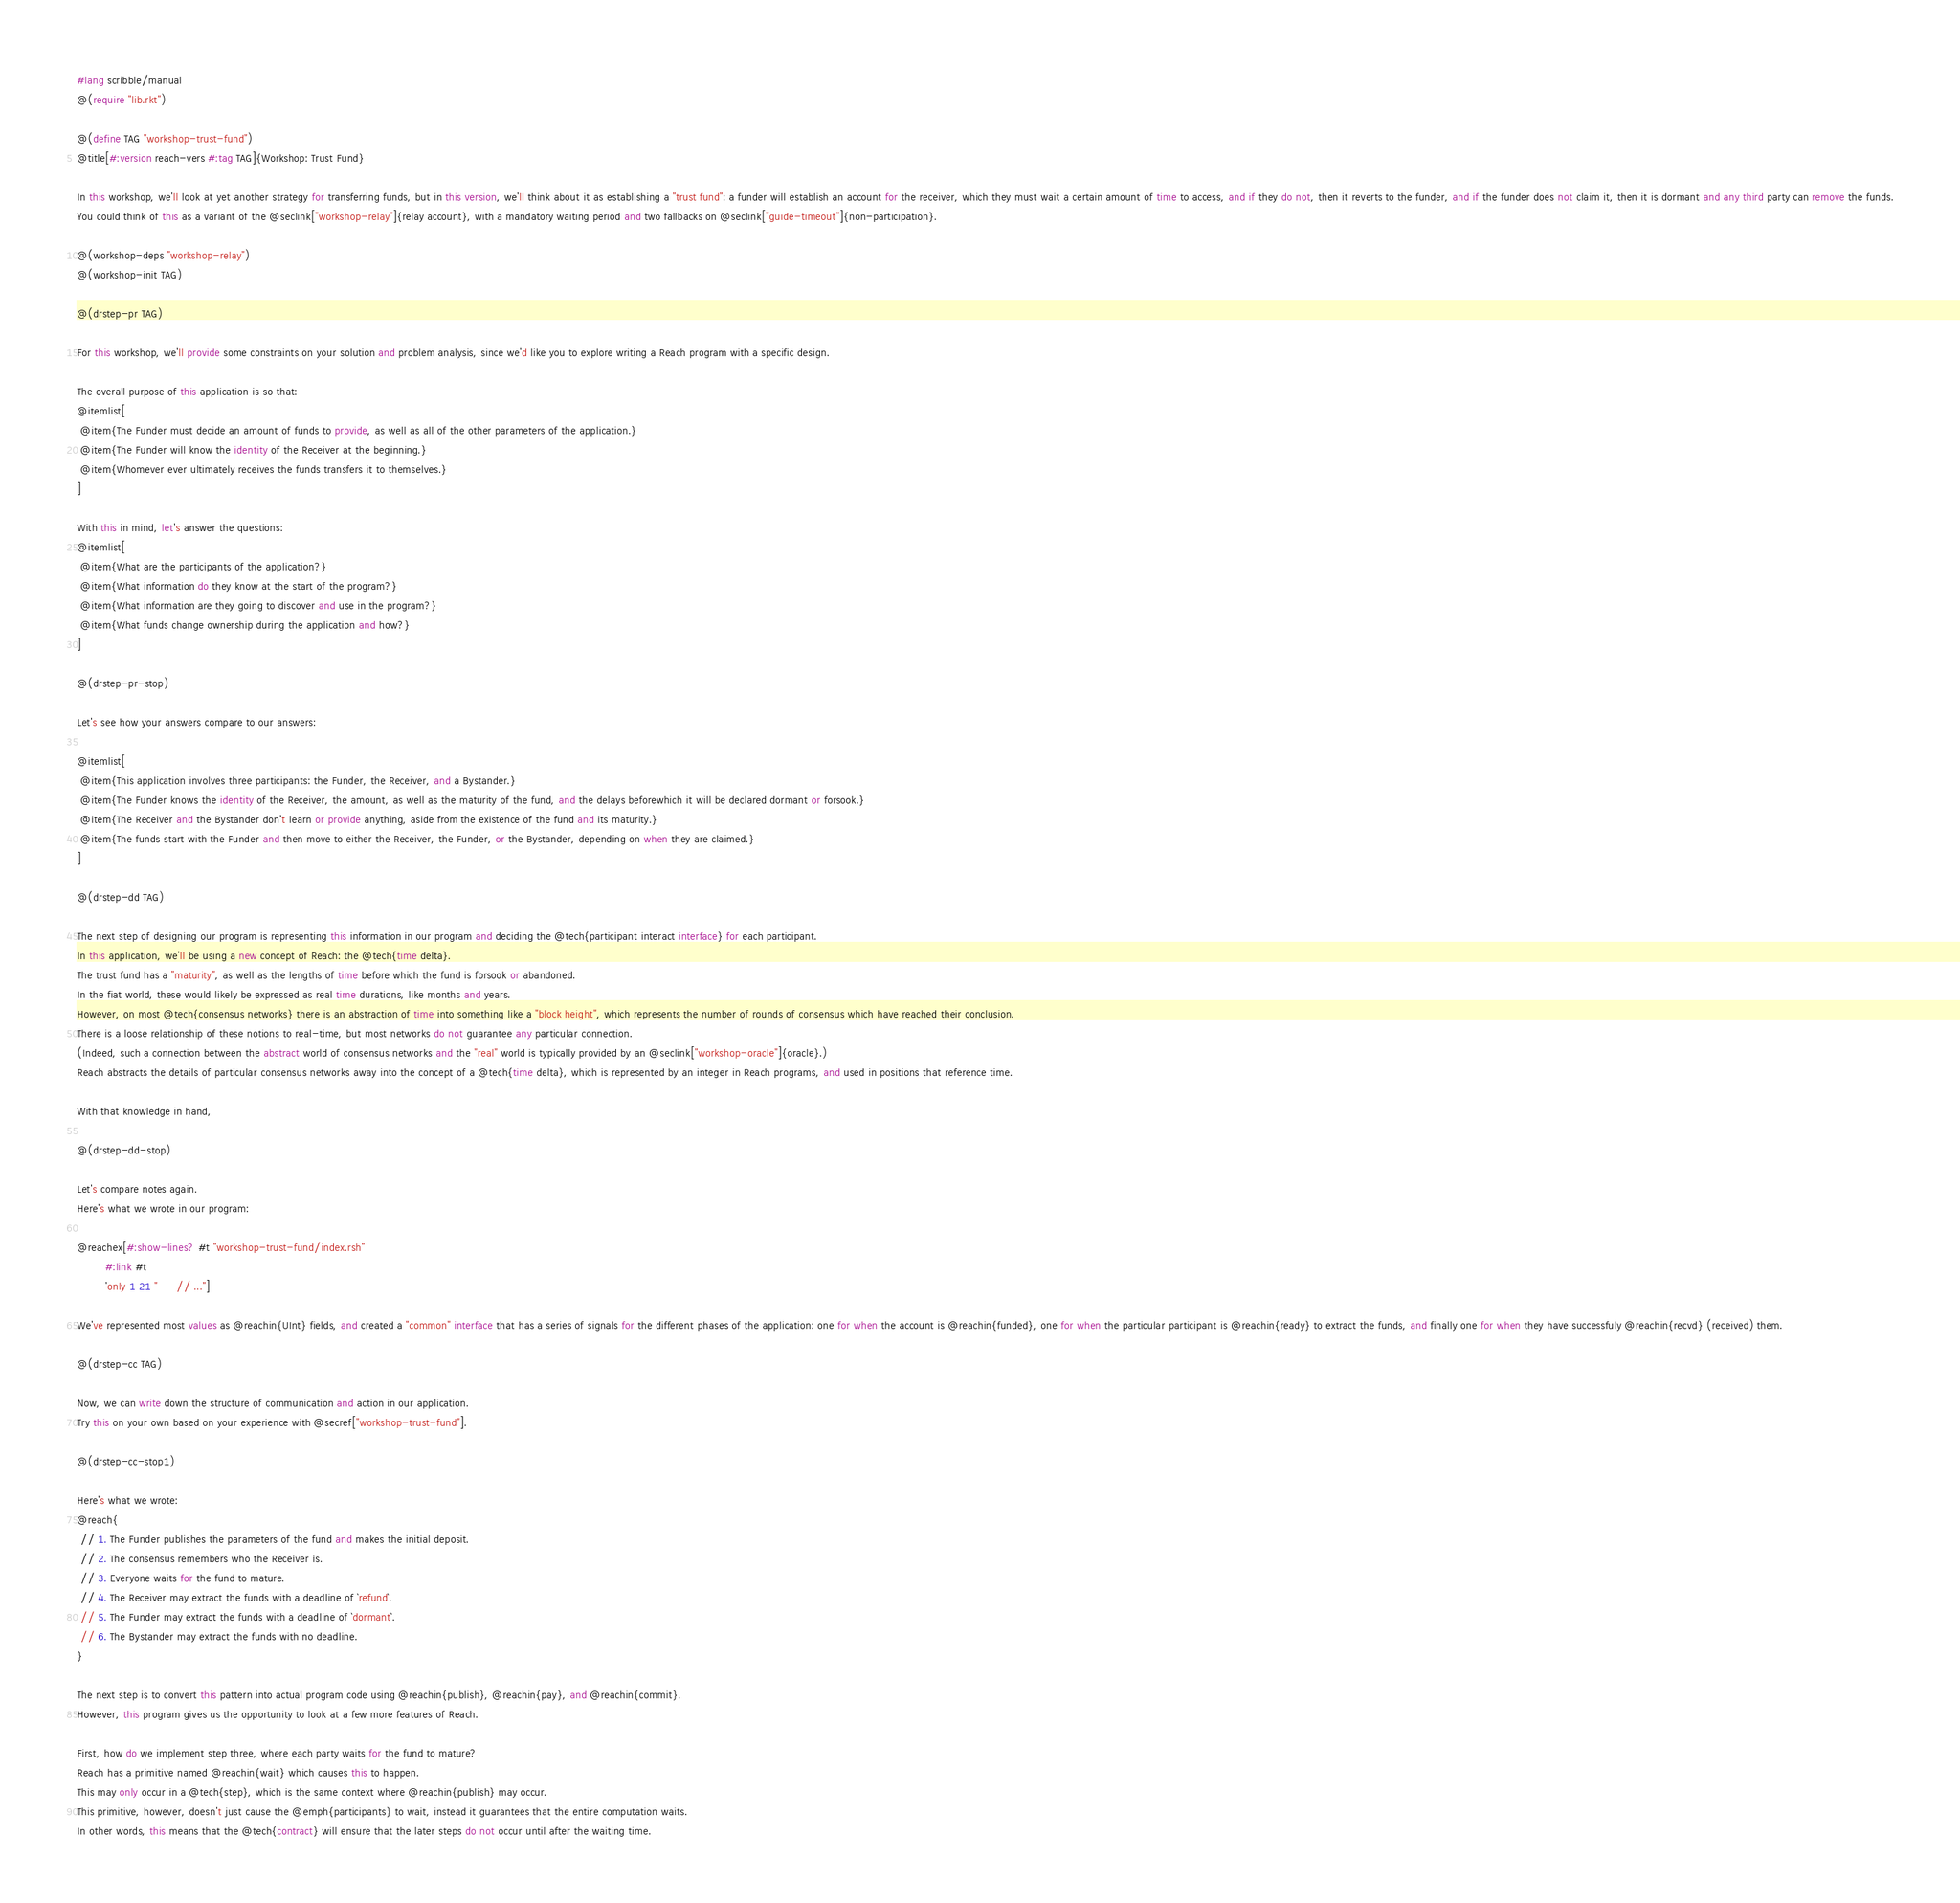Convert code to text. <code><loc_0><loc_0><loc_500><loc_500><_Racket_>#lang scribble/manual
@(require "lib.rkt")

@(define TAG "workshop-trust-fund")
@title[#:version reach-vers #:tag TAG]{Workshop: Trust Fund}

In this workshop, we'll look at yet another strategy for transferring funds, but in this version, we'll think about it as establishing a "trust fund": a funder will establish an account for the receiver, which they must wait a certain amount of time to access, and if they do not, then it reverts to the funder, and if the funder does not claim it, then it is dormant and any third party can remove the funds.
You could think of this as a variant of the @seclink["workshop-relay"]{relay account}, with a mandatory waiting period and two fallbacks on @seclink["guide-timeout"]{non-participation}.

@(workshop-deps "workshop-relay")
@(workshop-init TAG)

@(drstep-pr TAG)

For this workshop, we'll provide some constraints on your solution and problem analysis, since we'd like you to explore writing a Reach program with a specific design.

The overall purpose of this application is so that:
@itemlist[
 @item{The Funder must decide an amount of funds to provide, as well as all of the other parameters of the application.}
 @item{The Funder will know the identity of the Receiver at the beginning.}
 @item{Whomever ever ultimately receives the funds transfers it to themselves.}
]

With this in mind, let's answer the questions:
@itemlist[
 @item{What are the participants of the application?}
 @item{What information do they know at the start of the program?}
 @item{What information are they going to discover and use in the program?}
 @item{What funds change ownership during the application and how?}
]

@(drstep-pr-stop)

Let's see how your answers compare to our answers:

@itemlist[
 @item{This application involves three participants: the Funder, the Receiver, and a Bystander.}
 @item{The Funder knows the identity of the Receiver, the amount, as well as the maturity of the fund, and the delays beforewhich it will be declared dormant or forsook.}
 @item{The Receiver and the Bystander don't learn or provide anything, aside from the existence of the fund and its maturity.}
 @item{The funds start with the Funder and then move to either the Receiver, the Funder, or the Bystander, depending on when they are claimed.}
]

@(drstep-dd TAG)

The next step of designing our program is representing this information in our program and deciding the @tech{participant interact interface} for each participant.
In this application, we'll be using a new concept of Reach: the @tech{time delta}.
The trust fund has a "maturity", as well as the lengths of time before which the fund is forsook or abandoned.
In the fiat world, these would likely be expressed as real time durations, like months and years.
However, on most @tech{consensus networks} there is an abstraction of time into something like a "block height", which represents the number of rounds of consensus which have reached their conclusion.
There is a loose relationship of these notions to real-time, but most networks do not guarantee any particular connection.
(Indeed, such a connection between the abstract world of consensus networks and the "real" world is typically provided by an @seclink["workshop-oracle"]{oracle}.)
Reach abstracts the details of particular consensus networks away into the concept of a @tech{time delta}, which is represented by an integer in Reach programs, and used in positions that reference time.

With that knowledge in hand,

@(drstep-dd-stop)

Let's compare notes again.
Here's what we wrote in our program:

@reachex[#:show-lines? #t "workshop-trust-fund/index.rsh"
         #:link #t
         'only 1 21 "      // ..."]

We've represented most values as @reachin{UInt} fields, and created a "common" interface that has a series of signals for the different phases of the application: one for when the account is @reachin{funded}, one for when the particular participant is @reachin{ready} to extract the funds, and finally one for when they have successfuly @reachin{recvd} (received) them.

@(drstep-cc TAG)

Now, we can write down the structure of communication and action in our application.
Try this on your own based on your experience with @secref["workshop-trust-fund"].

@(drstep-cc-stop1)

Here's what we wrote:
@reach{
 // 1. The Funder publishes the parameters of the fund and makes the initial deposit.
 // 2. The consensus remembers who the Receiver is.
 // 3. Everyone waits for the fund to mature.
 // 4. The Receiver may extract the funds with a deadline of `refund`.
 // 5. The Funder may extract the funds with a deadline of `dormant`.
 // 6. The Bystander may extract the funds with no deadline.
}

The next step is to convert this pattern into actual program code using @reachin{publish}, @reachin{pay}, and @reachin{commit}.
However, this program gives us the opportunity to look at a few more features of Reach.

First, how do we implement step three, where each party waits for the fund to mature?
Reach has a primitive named @reachin{wait} which causes this to happen.
This may only occur in a @tech{step}, which is the same context where @reachin{publish} may occur.
This primitive, however, doesn't just cause the @emph{participants} to wait, instead it guarantees that the entire computation waits.
In other words, this means that the @tech{contract} will ensure that the later steps do not occur until after the waiting time.
</code> 